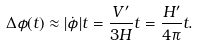Convert formula to latex. <formula><loc_0><loc_0><loc_500><loc_500>\Delta \phi ( t ) \approx | \dot { \phi } | t = \frac { V ^ { \prime } } { 3 H } t = \frac { H ^ { \prime } } { 4 \pi } t .</formula> 